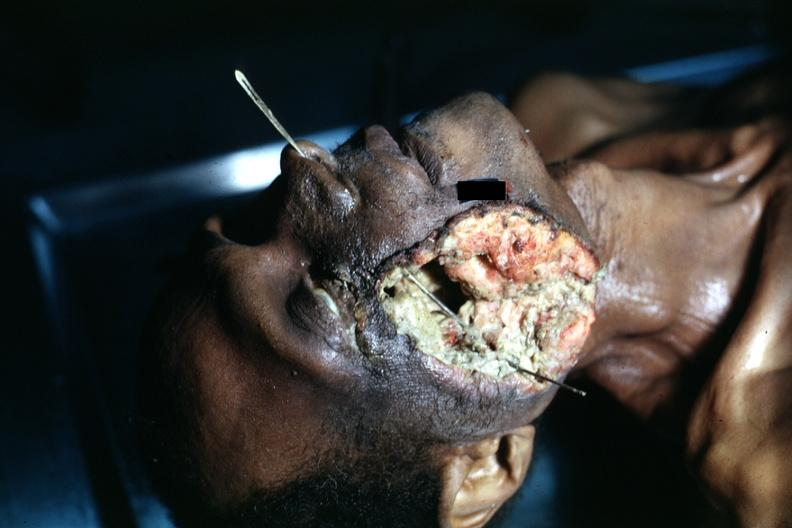s micrognathia triploid fetus present?
Answer the question using a single word or phrase. No 